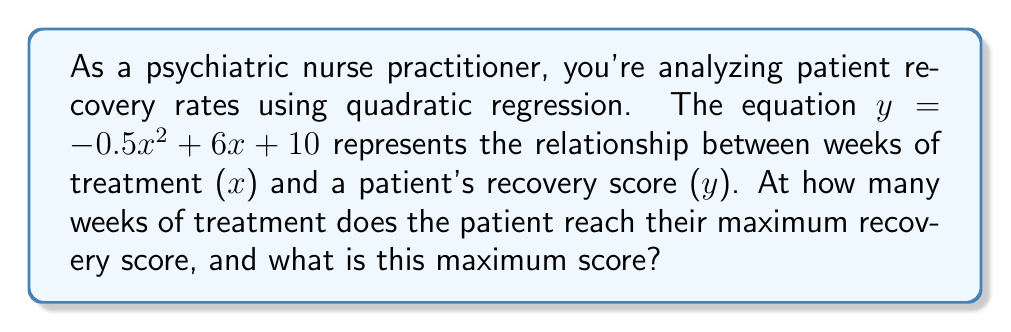Provide a solution to this math problem. To solve this problem, we need to follow these steps:

1) The quadratic function given is $y = -0.5x^2 + 6x + 10$, where $y$ is the recovery score and $x$ is the number of weeks of treatment.

2) For a quadratic function in the form $y = ax^2 + bx + c$, the x-coordinate of the vertex represents the point where y reaches its maximum (if $a < 0$) or minimum (if $a > 0$).

3) The formula for the x-coordinate of the vertex is $x = -\frac{b}{2a}$, where $a$ and $b$ are the coefficients of $x^2$ and $x$ respectively.

4) In this case, $a = -0.5$ and $b = 6$. Let's calculate x:

   $x = -\frac{6}{2(-0.5)} = -\frac{6}{-1} = 6$

5) This means the patient reaches their maximum recovery score after 6 weeks of treatment.

6) To find the maximum recovery score, we need to substitute $x = 6$ into the original equation:

   $y = -0.5(6)^2 + 6(6) + 10$
   $y = -0.5(36) + 36 + 10$
   $y = -18 + 36 + 10$
   $y = 28$

Therefore, the maximum recovery score is 28.
Answer: The patient reaches their maximum recovery score after 6 weeks of treatment, and the maximum recovery score is 28. 